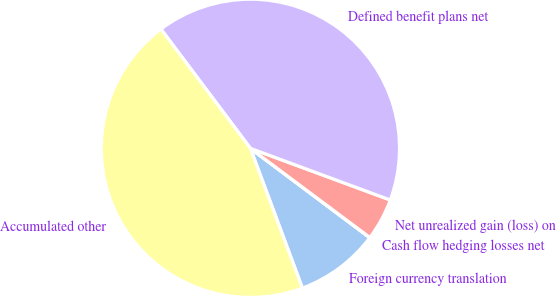Convert chart. <chart><loc_0><loc_0><loc_500><loc_500><pie_chart><fcel>Foreign currency translation<fcel>Cash flow hedging losses net<fcel>Net unrealized gain (loss) on<fcel>Defined benefit plans net<fcel>Accumulated other<nl><fcel>9.1%<fcel>0.03%<fcel>4.57%<fcel>40.88%<fcel>45.42%<nl></chart> 